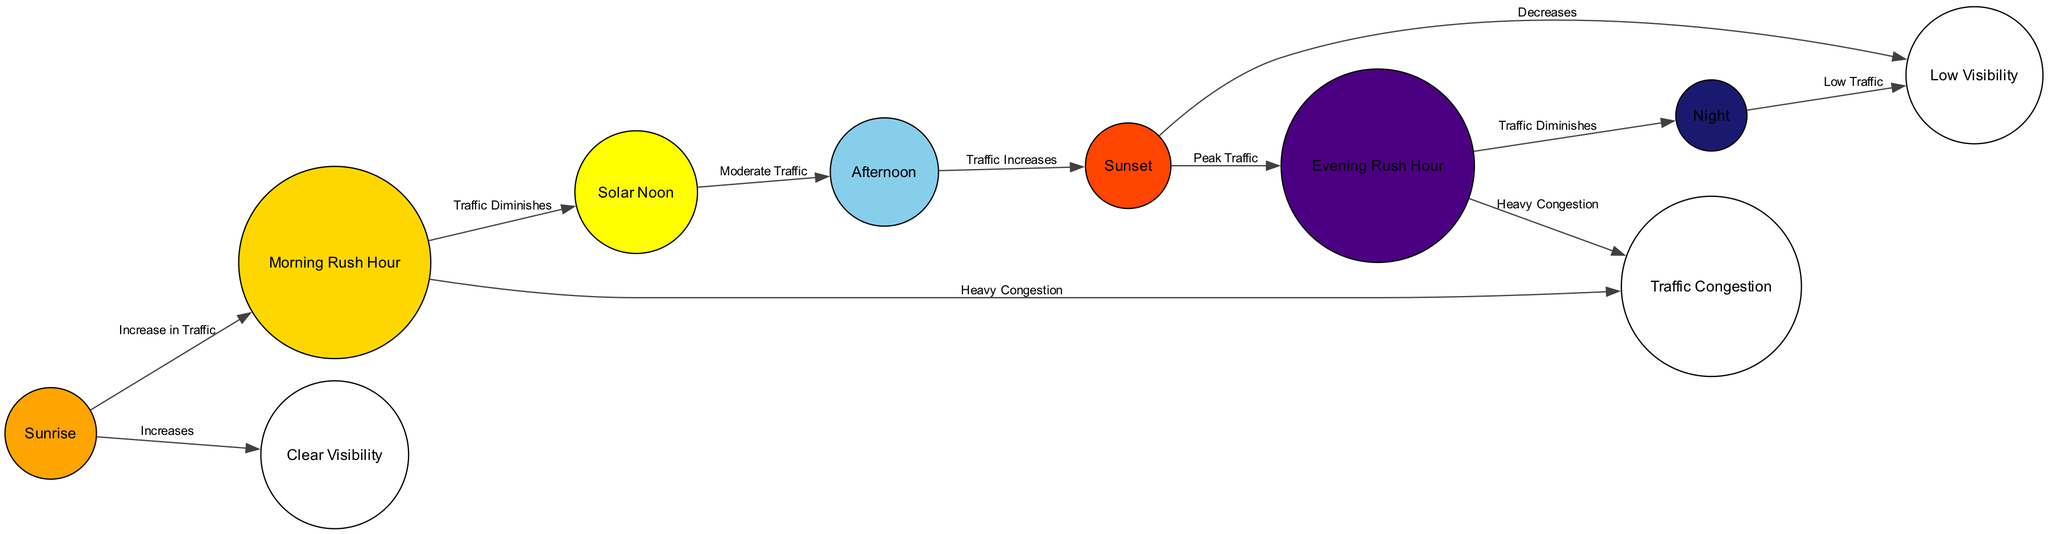What event follows 'Sunrise' in the diagram? According to the diagram flow, 'Sunrise' directly leads to 'Morning Rush Hour,' as indicated by the connecting edge between these two nodes.
Answer: Morning Rush Hour How many nodes are present in the diagram? By counting the nodes listed in the diagram data, there are a total of 10 distinct nodes.
Answer: 10 What does 'Solar Noon' lead to? Observing the edges, 'Solar Noon' connects to 'Afternoon,' showing the transition from one time to another.
Answer: Afternoon Which two events are associated with 'Heavy Congestion'? The diagram shows that 'Heavy Congestion' is linked to both 'Morning Rush Hour' and 'Evening Rush Hour' through direct edges connecting these nodes.
Answer: Morning Rush Hour and Evening Rush Hour Does 'Sunset' lead to an increase or decrease in visibility? The edge from 'Sunset' to 'Low Visibility' indicates that the visibility decreases following this event.
Answer: Decreases What traffic pattern occurs during 'Afternoon'? The diagram connects 'Afternoon' to 'Traffic Increases,' indicating that traffic patterns tend to rise during this period.
Answer: Traffic Increases Which nodes are directly connected by the edge labeled 'Increase in Traffic'? The edge labeled 'Increase in Traffic' connects 'Sunrise' and 'Morning Rush Hour,' indicating the relationship between these two time periods in terms of city traffic.
Answer: Sunrise and Morning Rush Hour How does traffic change from 'Evening Rush Hour' to 'Night'? The diagram shows an edge from 'Evening Rush Hour' to 'Night,' labeled 'Traffic Diminishes,' indicating that traffic reduces significantly during this transition.
Answer: Traffic Diminishes 